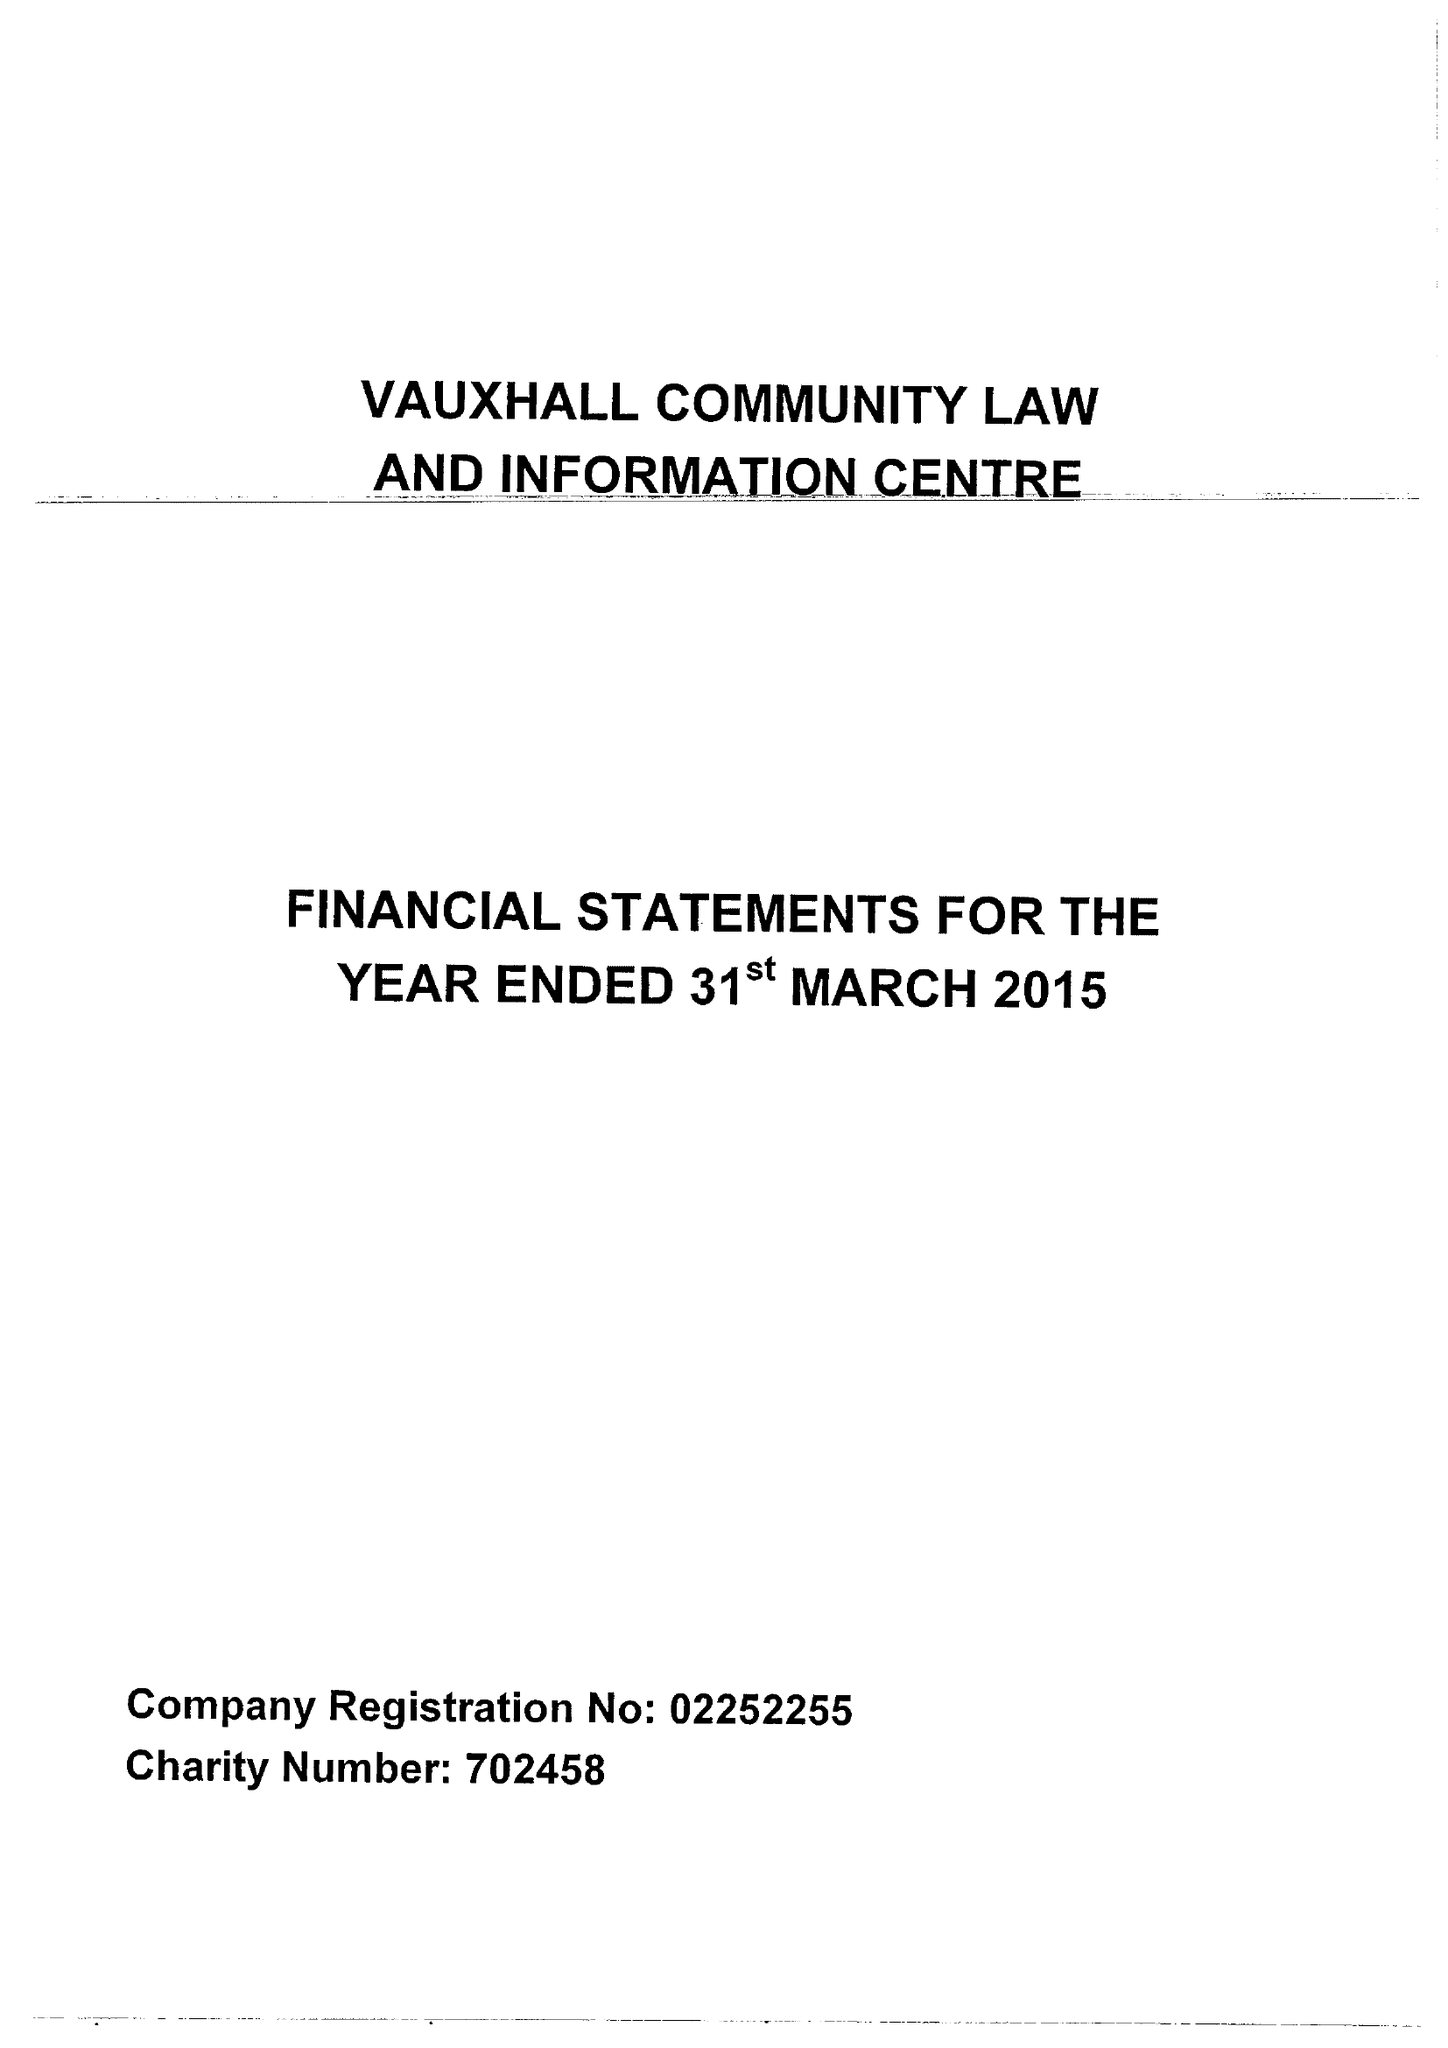What is the value for the report_date?
Answer the question using a single word or phrase. 2015-03-31 